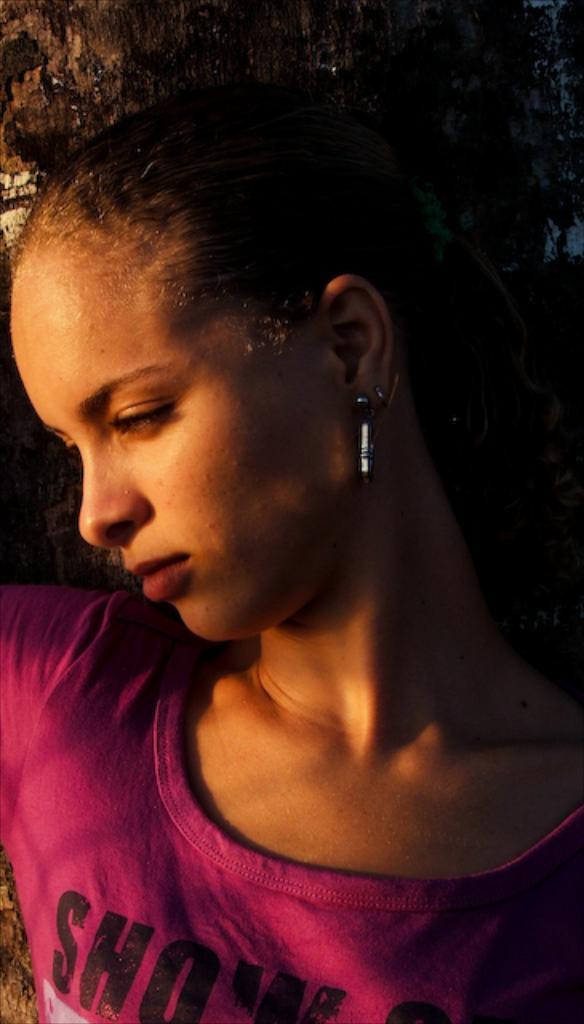Please provide a concise description of this image. In this picture, we see the woman is wearing the purple T-shirt. She might be posing for the photo. Behind her, we see the wall or the stem of the tree. 